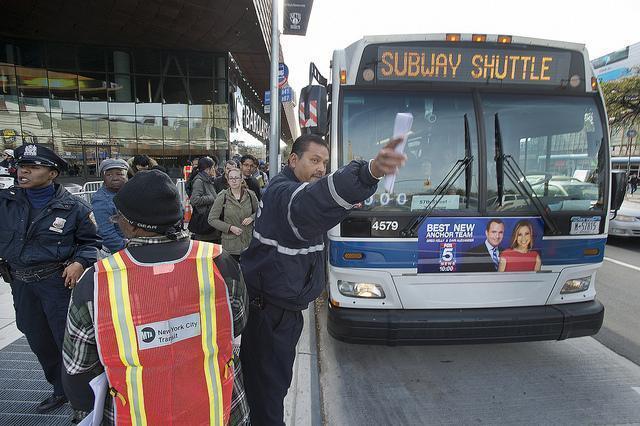What profession is the black man in the blue cap on the left?
Indicate the correct response by choosing from the four available options to answer the question.
Options: Fireman, teacher, police officer, lawyer. Police officer. 